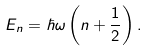<formula> <loc_0><loc_0><loc_500><loc_500>E _ { n } = \hbar { \omega } \left ( n + { \frac { 1 } { 2 } } \right ) .</formula> 